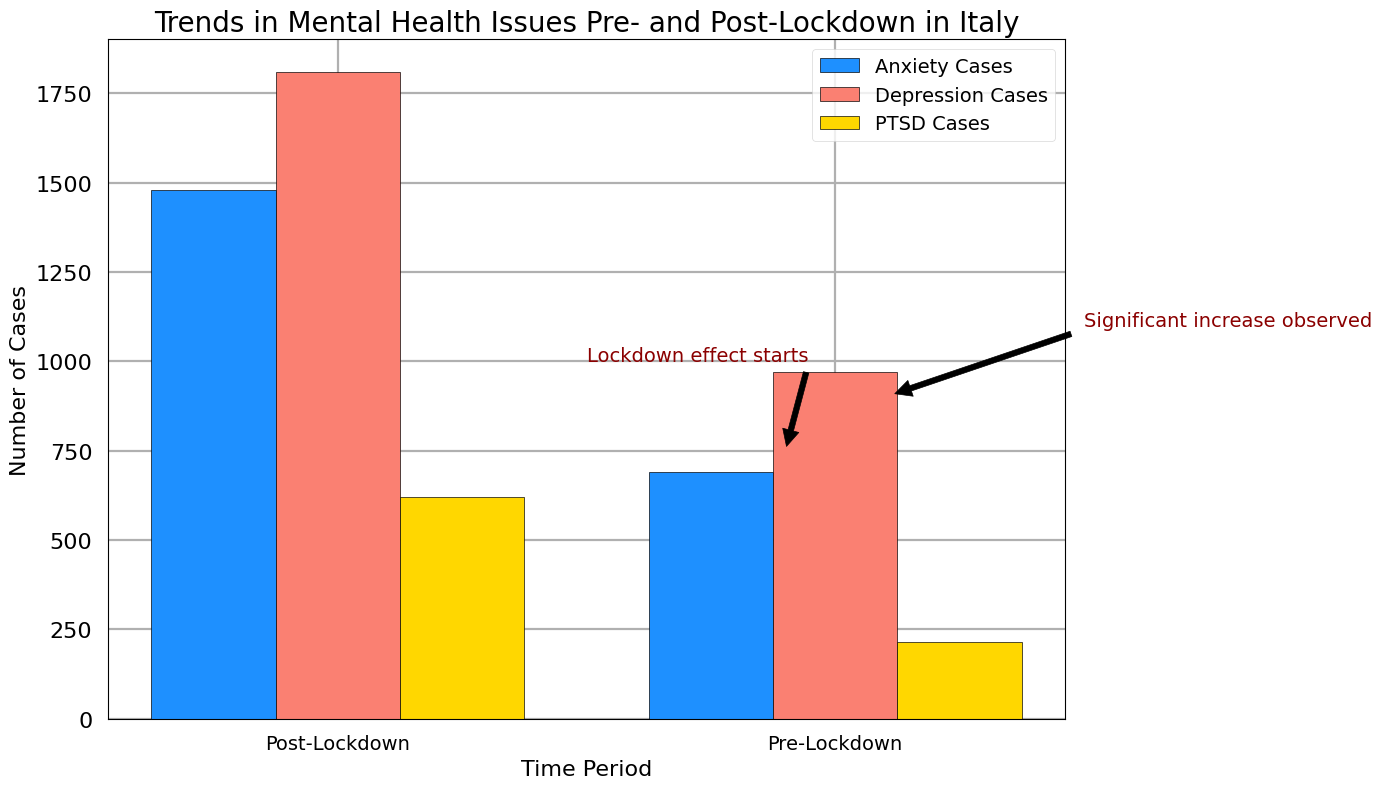what is the total number of depression cases reported post-lockdown? To find the total number of depression cases reported post-lockdown, refer to the sum of the depression cases across all regions in the post-lockdown period from the bar chart. Each bar represents a separate issue with different colors, and the depression cases are illustrated in salmon color.
Answer: 1810 which region saw the highest increase in anxiety cases post-lockdown? To determine which region saw the highest increase in anxiety cases post-lockdown, look at the difference in the height of the dodger blue bars before and after the lockdown period. Compare the differences between the pre-lockdown and post-lockdown heights for each region.
Answer: Lombardy which mental health issue had the lowest total cases pre-lockdown? To find the mental health issue with the lowest total cases pre-lockdown, compare the heights of the grouped bars representing each mental health issue in the pre-lockdown period. Identify the issue with the shortest average bar height.
Answer: PTSD how do the total anxiety cases post-lockdown compare to the total depression cases pre-lockdown? To compare the total anxiety cases post-lockdown to the total depression cases pre-lockdown, look at the heights of the dodger blue bars in the post-lockdown period and the salmon bars in the pre-lockdown period. Sum up the heights for each period and compare.
Answer: Higher post-lockdown what annotation is pointing at approximately 750 cases and what does it indicate? Look at the annotation placed near where the case count is around 750. The annotation text and arrow help identify and explain an important aspect represented in the figure.
Answer: Lockdown effect starts which mental health issue experienced the most significant increase from pre- to post-lockdown? To identify the mental health issue with the most significant increase from pre- to post-lockdown, compare the differences in the bar heights for each issue across the two time periods. The issue with the largest height difference indicates the most significant increase.
Answer: Anxiety cases what is the sum of PTSD cases in Campania post-lockdown? To find the sum of PTSD cases in Campania post-lockdown, locate the gold-colored bar for PTSD cases in Campania in the post-lockdown period and refer to its height value.
Answer: 90 in which time period does the annotation "Significant increase observed" appear and what is its significance? Locate the annotation "Significant increase observed" based on its positioning in the chart. This annotation explains an observed trend regarding the change in mental health issue counts.
Answer: Post-lockdown how many more depression cases were reported in Lazio post-lockdown compared to pre-lockdown? To determine how many more depression cases were reported in Lazio post-lockdown compared to pre-lockdown, subtract the count of depression cases in the pre-lockdown period (height of the salmon bar) from the post-lockdown period (height of the salmon bar) for Lazio.
Answer: 140 